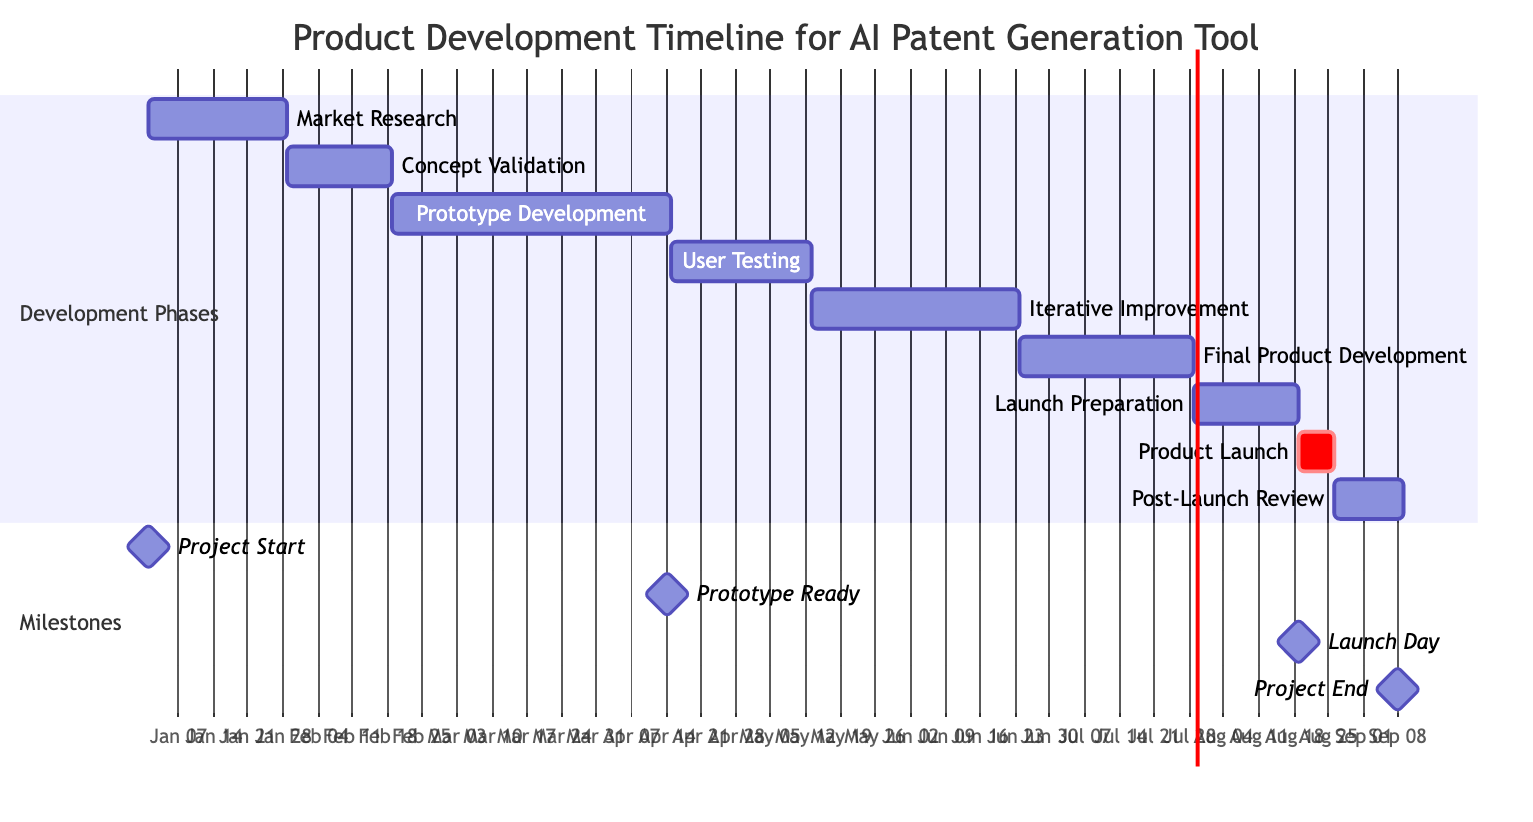What is the total duration of the 'User Testing' phase? The 'User Testing' phase has a duration of 4 weeks as specified in the timeline.
Answer: 4 weeks When does 'Prototype Development' start? According to the diagram, 'Prototype Development' starts on February 19, 2024.
Answer: February 19, 2024 How many weeks are allocated for 'Iterative Improvement'? The duration for 'Iterative Improvement' is stated as 6 weeks, which can be seen directly in the timeline.
Answer: 6 weeks What milestone occurs just before 'Launch Day'? The timeline shows that 'Prototype Ready' is the milestone immediately before 'Launch Day,' occurring on April 14, 2024, while 'Launch Day' is on August 19, 2024.
Answer: Prototype Ready Which phase has the longest duration? By comparing the durations in the diagram, 'Prototype Development' has the longest duration at 8 weeks.
Answer: Prototype Development What is the end date of the 'Final Product Development' phase? The 'Final Product Development' phase ends on July 28, 2024, as indicated in the Gantt chart.
Answer: July 28, 2024 What is the duration between 'Launch Preparation' and 'Product Launch'? The duration between 'Launch Preparation' (which ends on August 18, 2024) and 'Product Launch' (which starts on August 19, 2024) is 1 day.
Answer: 1 day How many phases are there in total? There are 9 phases listed in the diagram for the product development timeline. This includes all steps before and after the launch.
Answer: 9 What is the start date of the project? The project starts on January 1, 2024, as clearly stated at the start of the Gantt chart.
Answer: January 1, 2024 